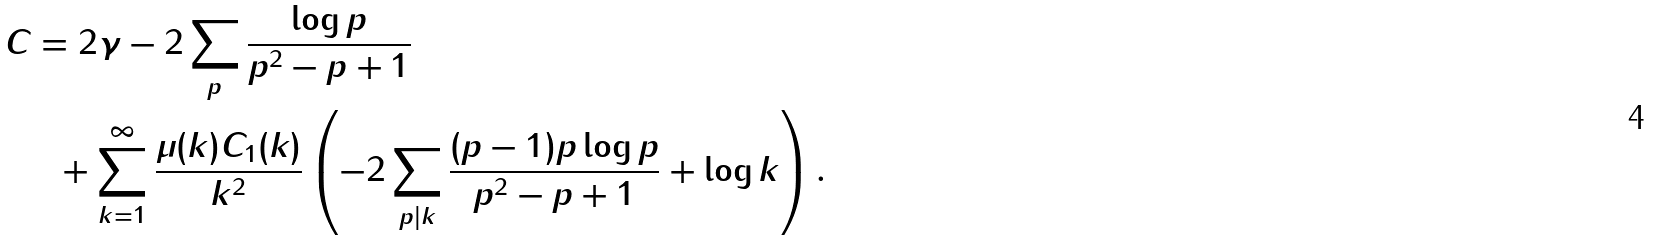<formula> <loc_0><loc_0><loc_500><loc_500>C & = 2 \gamma - 2 \sum _ { p } \frac { \log p } { p ^ { 2 } - p + 1 } \\ & \ \ + \sum _ { k = 1 } ^ { \infty } \frac { \mu ( k ) C _ { 1 } ( k ) } { k ^ { 2 } } \left ( - 2 \sum _ { p | k } \frac { ( p - 1 ) p \log p } { p ^ { 2 } - p + 1 } + \log k \right ) .</formula> 